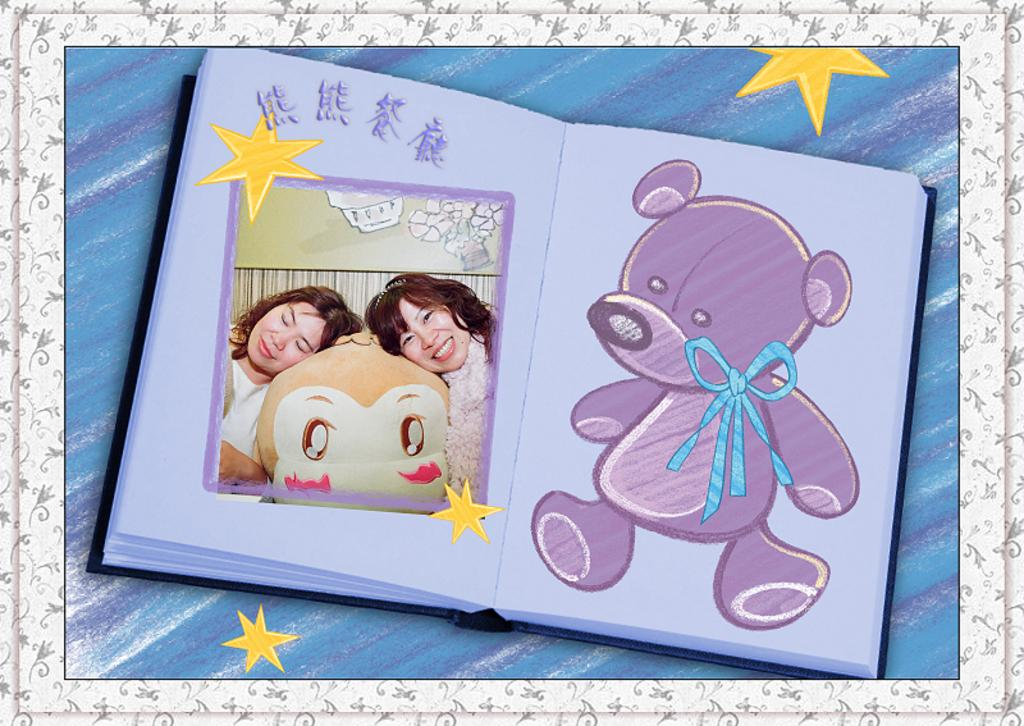What object can be seen in the image related to reading or learning? There is a book in the image. Who can be seen on the left side of the image? There are two women on the left side of the image. What type of artwork is on the right side of the image? There is a teddy painting on the right side of the image. How many yellow stars are present in the image? There are four yellow color stars in the image. Has the image been altered in any way? Yes, the image has been edited. What type of government is depicted in the image? There is no depiction of a government in the image. How many potatoes are present in the image? There are no potatoes present in the image. 